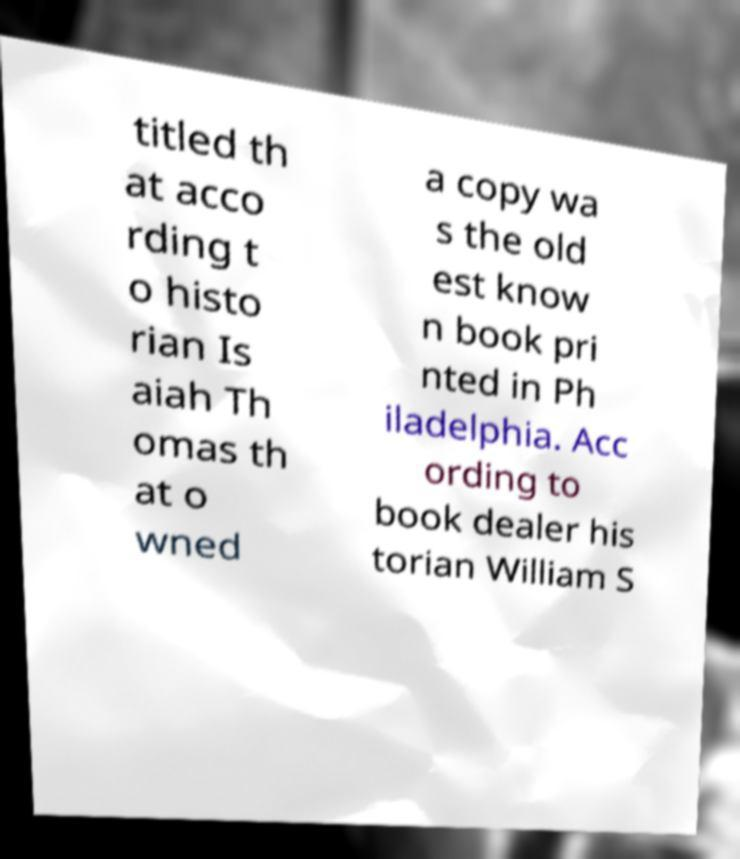I need the written content from this picture converted into text. Can you do that? titled th at acco rding t o histo rian Is aiah Th omas th at o wned a copy wa s the old est know n book pri nted in Ph iladelphia. Acc ording to book dealer his torian William S 